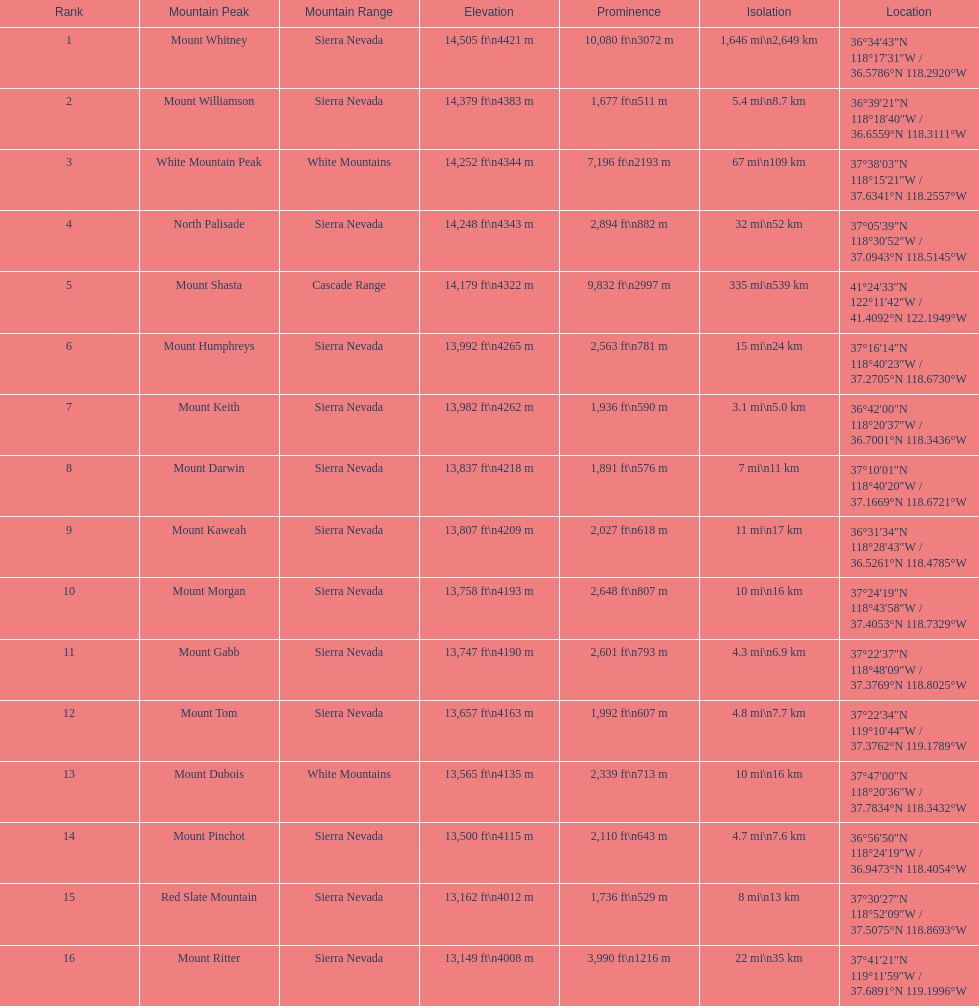Which is taller, mount humphreys or mount kaweah. Mount Humphreys. 